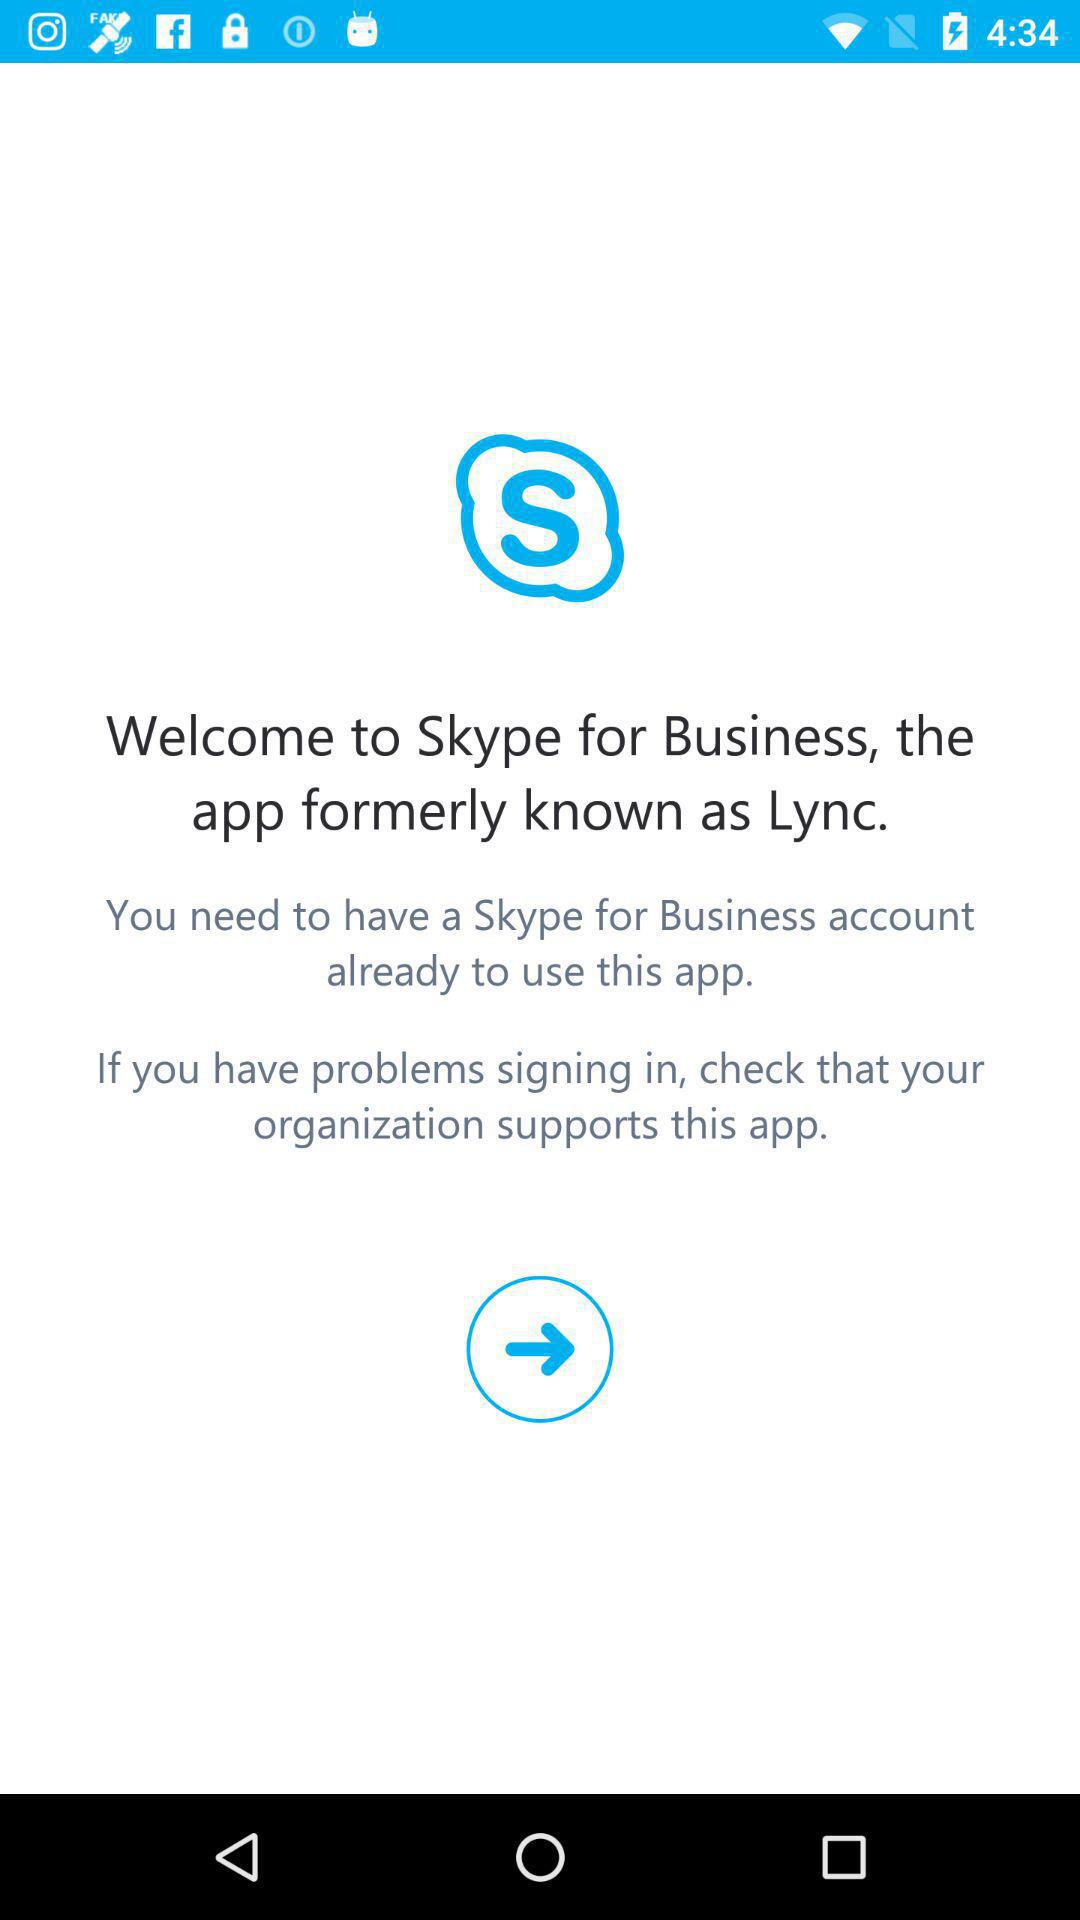What was the previous name of the application Skype for Business? Skype for Business's previous name was Lync. 